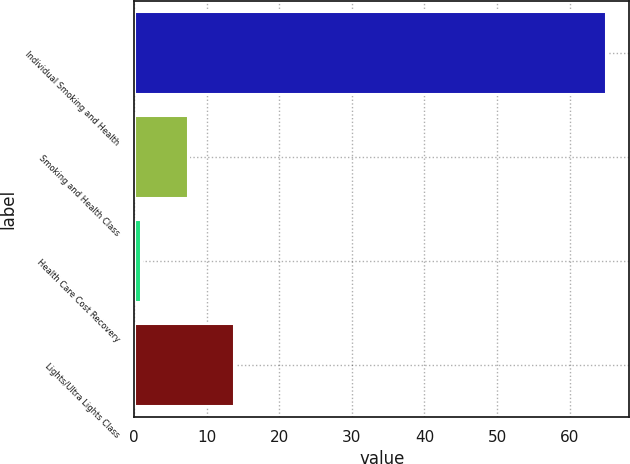Convert chart. <chart><loc_0><loc_0><loc_500><loc_500><bar_chart><fcel>Individual Smoking and Health<fcel>Smoking and Health Class<fcel>Health Care Cost Recovery<fcel>Lights/Ultra Lights Class<nl><fcel>65<fcel>7.4<fcel>1<fcel>13.8<nl></chart> 